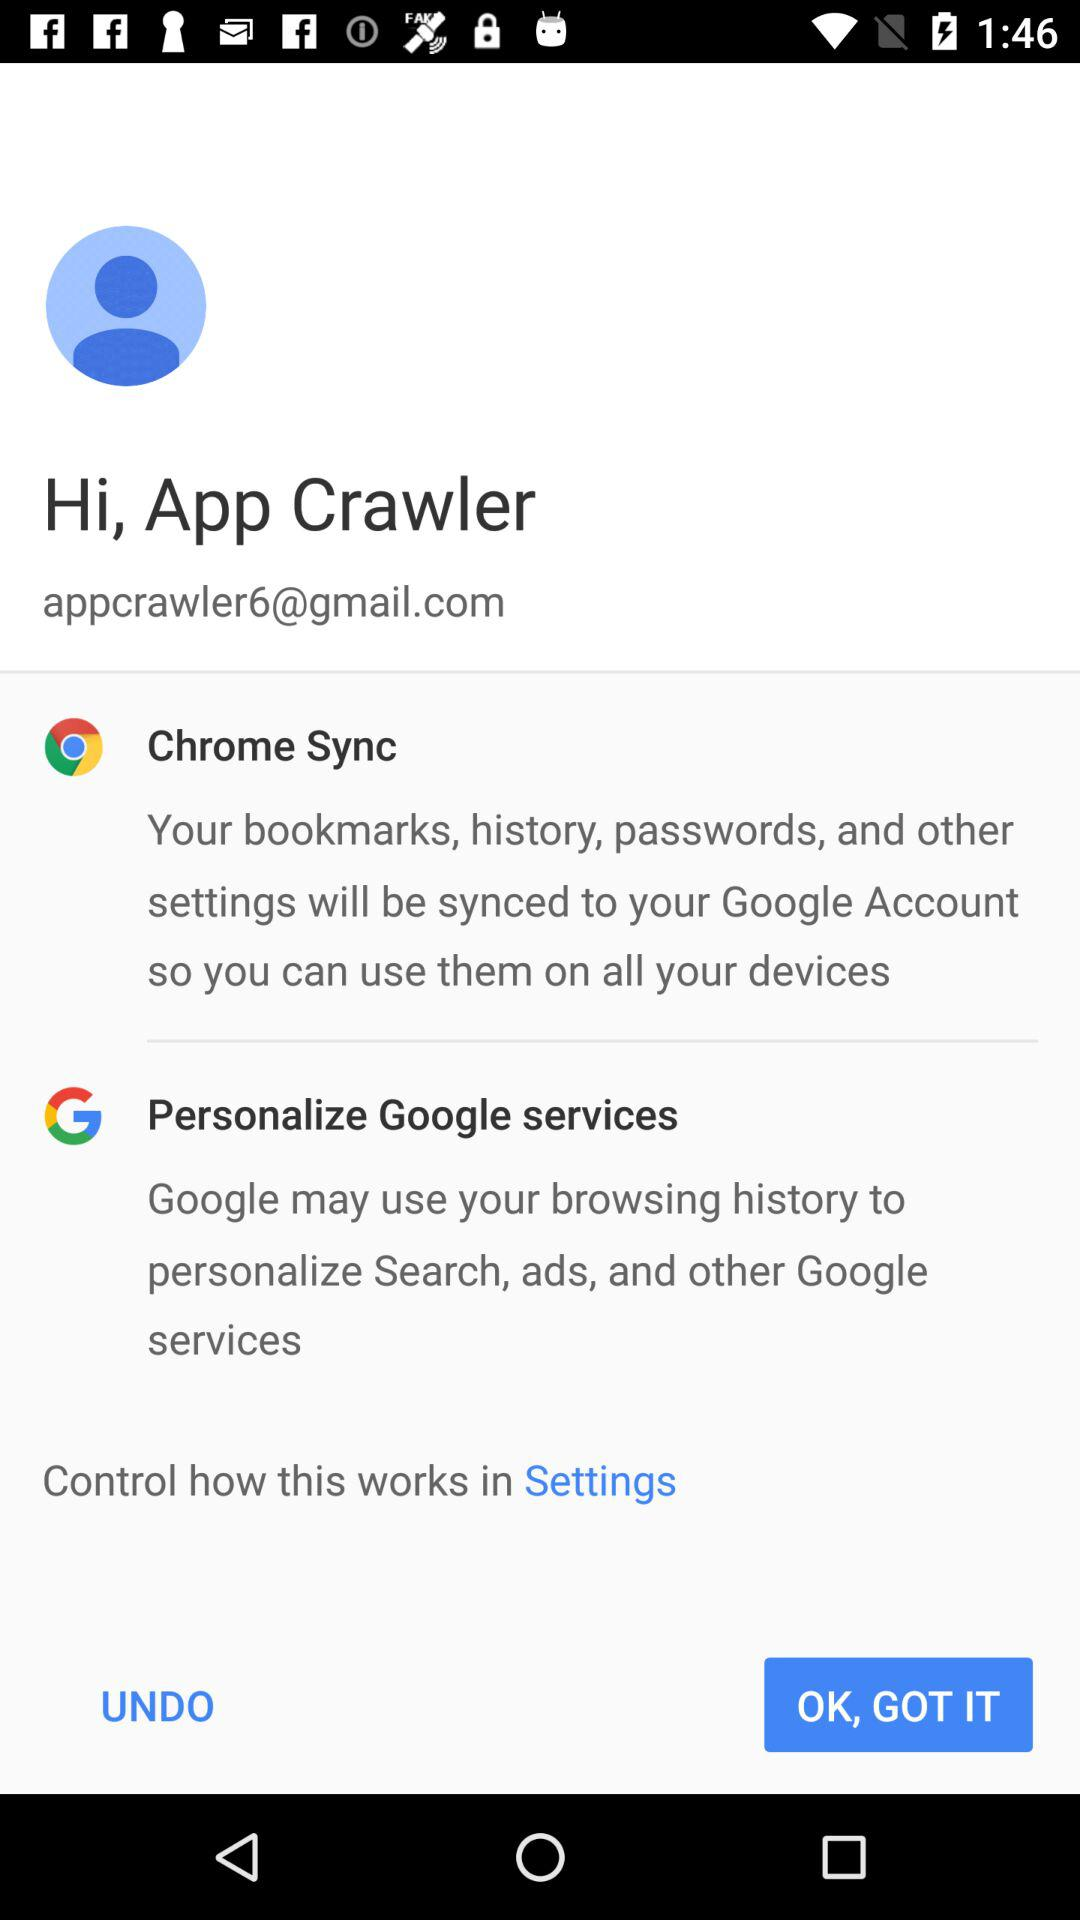What is the user name? The user name is App Crawler. 